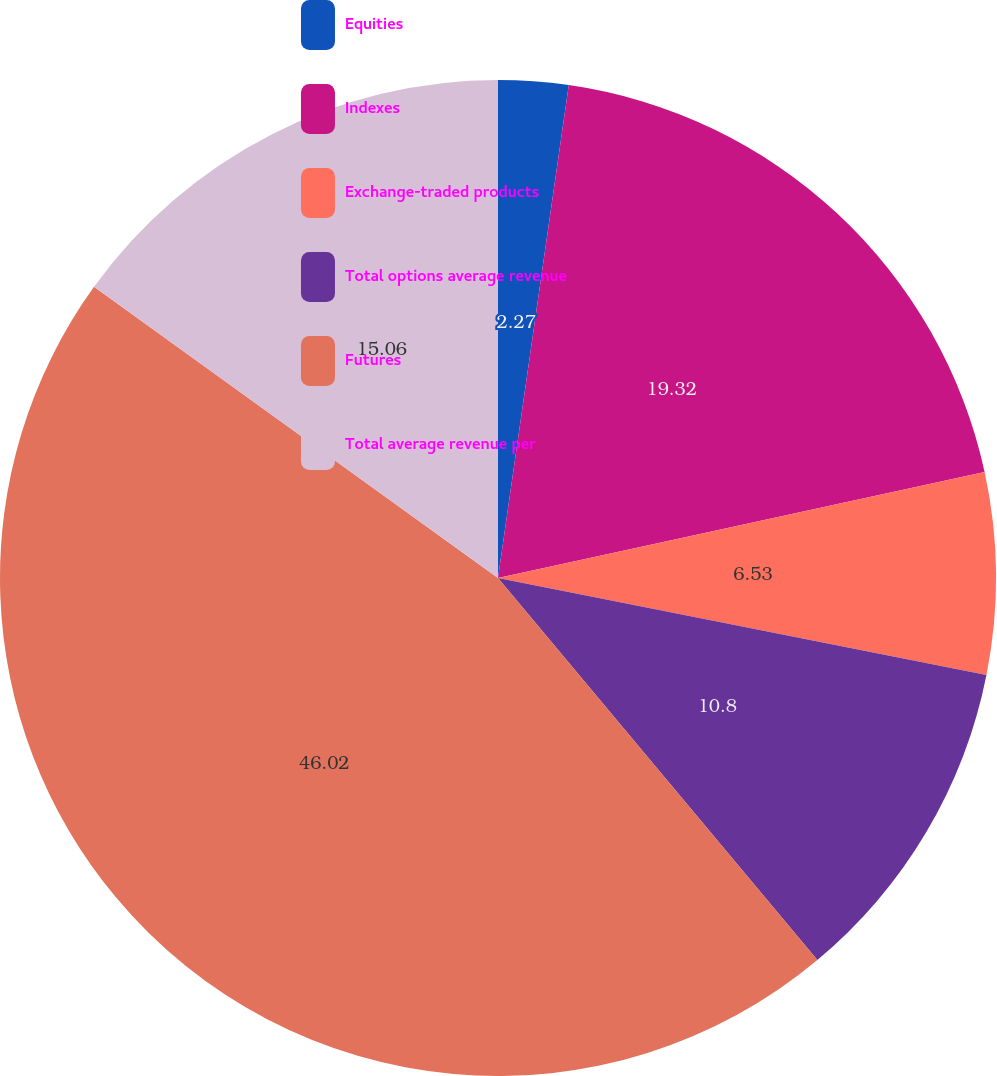<chart> <loc_0><loc_0><loc_500><loc_500><pie_chart><fcel>Equities<fcel>Indexes<fcel>Exchange-traded products<fcel>Total options average revenue<fcel>Futures<fcel>Total average revenue per<nl><fcel>2.27%<fcel>19.32%<fcel>6.53%<fcel>10.8%<fcel>46.02%<fcel>15.06%<nl></chart> 